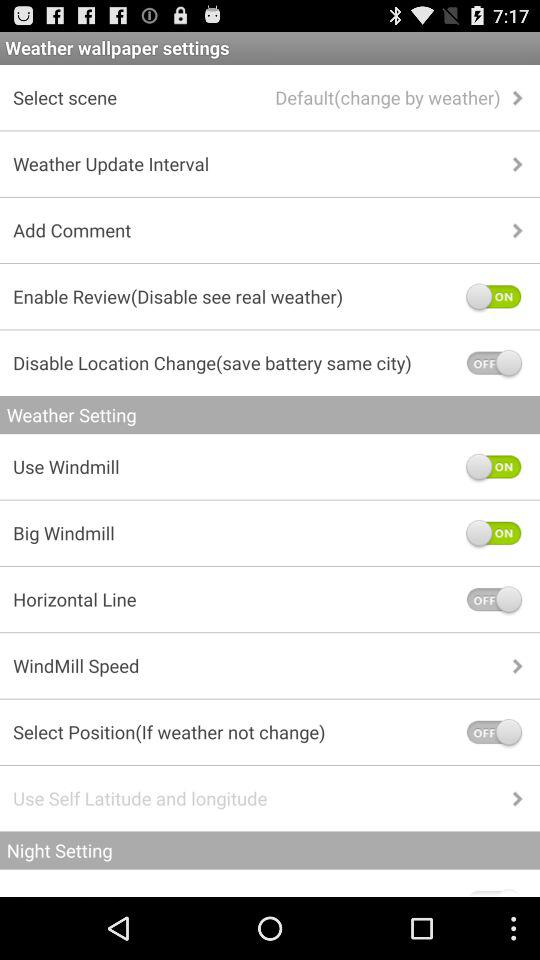What is the status of "Use Windmill"? The status is "on". 